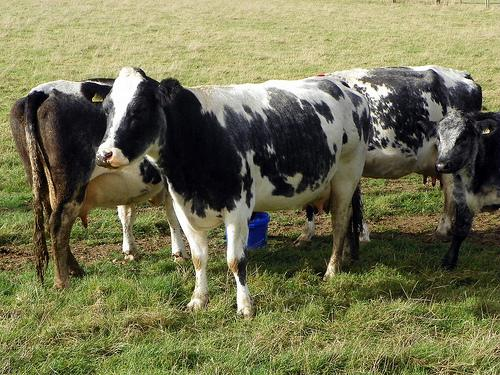What is unique about the cow that is facing the camera? The cow facing the camera has a yellow tag in its ear. What color is the tail of one of the cows? The tail of one of the cows is black. How many legs does the cow in the front have? The cow in the front has four legs. What does the sentence "cow is next to cow" mean in this context? It means that there are cows standing close to each other in the image. Identify one object in the image that is not a cow. A blue pail is present under the cows. Can you create a summary of the scene in the image? A group of cows standing on a grass field, with some cows facing the camera and others interacting, a blue pail, and a fence in the background. How many cows are there in the group? There are several cows in the group. Tell me about the surface the cows in the image are standing on. The cows are standing on a green grass field. What is a notable feature of the image apart from the cows? A blue bucket is present under one of the cows. Identify an interaction between two cows in the image. One cow is standing in front of another cow. Identify the location and dimensions of a blue bucket in the image. A blue bucket is located at X:241 Y:209 with Width:35 and Height:35. Describe the sentiment of the image. Neutral and calm, as it depicts a group of cows in a field. Detect the cow's front legs and provide their dimensions. Cow's front legs are located at X:166 Y:191 with Width 100 and Height:100. What object attribute can be observed for the cow's tail? It's a long tail with left-top corner coordinates X:21 Y:97, Width:32 and Height:32. What is the location and size of the bottom of a fence in the image? The bottom of a fence is located at X:397 Y:1 with Width:102 and Height:102. Where can the cow with a yellow tag in its ear be found? At coordinates X:86 Y:92 with Width:18 and Height:18. Is there a blue pail under any of the cows? If so, provide its details. Yes, a blue pail under the cows is located at X:241 Y:208 with Width:31 and Height:31. What does the cow facing the camera look like? A cow's front face with left-top corner coordinates X:81 Y:63, Width:90 and Height:90. What is the dirt patch's position and size? A patch of dirt is located at X:3 Y:237 with Width:133 and Height:133. Point out the position and dimensions of a small calf in the image. Small calf is located at X:426 Y:108 with Width:70 and Height:70. What position and size can describe the cows' nipples in the image? The cows' nipples are at position X:301 Y:198 with Width:37 and Height:37. Identify areas in the image where cows are interacting with one another. Cow is next to cow at X:8 Y:79 Width:186 Height:186; Cow is in front of cow at X:79 Y:65 Width:297 Height:297. Describe three of the captioned legs of the cow. Cow front left leg: X:218 Y:190 Width:44 Height:44; Cow front right leg: X:173 Y:211 Width:40 Height:40; Cow back right leg: X:38 Y:157 Width:45 Height:45. Please give details about the quality of the image. The image quality is good with clear object boundaries and distinct colors. How do the cows appear to be standing in the image? All of the cows are standing on the grass field. How would you describe the cows' surroundings? The cows are in a grass field with a patch of dirt and the bottom of a fence. 